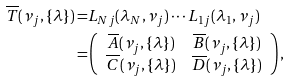Convert formula to latex. <formula><loc_0><loc_0><loc_500><loc_500>\overline { T } ( \nu _ { j } , \{ \lambda \} ) = & L _ { N j } ( \lambda _ { N } , \nu _ { j } ) \cdots L _ { 1 j } ( \lambda _ { 1 } , \nu _ { j } ) \\ = & \left ( \begin{array} { c c } \overline { A } ( \nu _ { j } , \{ \lambda \} ) & \overline { B } ( \nu _ { j } , \{ \lambda \} ) \\ \overline { C } ( \nu _ { j } , \{ \lambda \} ) & \overline { D } ( \nu _ { j } , \{ \lambda \} ) \end{array} \right ) ,</formula> 